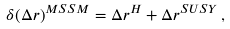Convert formula to latex. <formula><loc_0><loc_0><loc_500><loc_500>\delta ( \Delta r ) ^ { M S S M } = \Delta r ^ { H } + \Delta r ^ { S U S Y } \, ,</formula> 